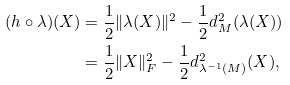<formula> <loc_0><loc_0><loc_500><loc_500>( h \circ \lambda ) ( X ) & = \frac { 1 } { 2 } \| \lambda ( X ) \| ^ { 2 } - \frac { 1 } { 2 } d ^ { 2 } _ { M } ( \lambda ( X ) ) \\ & = \frac { 1 } { 2 } \| X \| ^ { 2 } _ { F } - \frac { 1 } { 2 } d ^ { 2 } _ { \lambda ^ { - 1 } ( M ) } ( X ) ,</formula> 